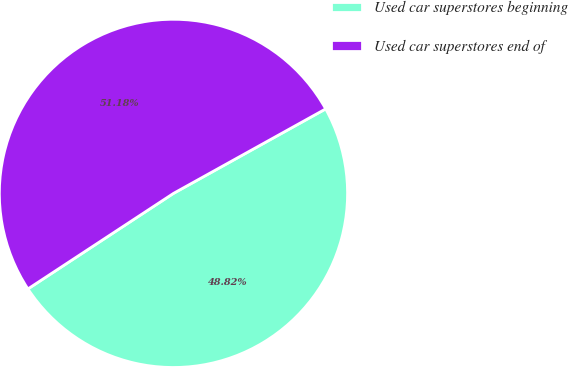Convert chart to OTSL. <chart><loc_0><loc_0><loc_500><loc_500><pie_chart><fcel>Used car superstores beginning<fcel>Used car superstores end of<nl><fcel>48.82%<fcel>51.18%<nl></chart> 